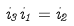Convert formula to latex. <formula><loc_0><loc_0><loc_500><loc_500>i _ { 3 } i _ { 1 } = i _ { 2 }</formula> 